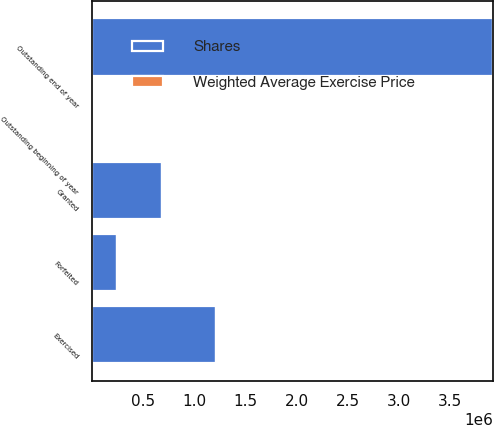<chart> <loc_0><loc_0><loc_500><loc_500><stacked_bar_chart><ecel><fcel>Outstanding beginning of year<fcel>Granted<fcel>Exercised<fcel>Forfeited<fcel>Outstanding end of year<nl><fcel>Shares<fcel>23.37<fcel>676038<fcel>1.20353e+06<fcel>243965<fcel>3.9202e+06<nl><fcel>Weighted Average Exercise Price<fcel>21.12<fcel>23.37<fcel>18.82<fcel>22.96<fcel>22.09<nl></chart> 